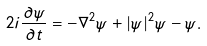Convert formula to latex. <formula><loc_0><loc_0><loc_500><loc_500>2 i \frac { \partial \psi } { \partial t } = - \nabla ^ { 2 } \psi + | \psi | ^ { 2 } \psi - \psi .</formula> 